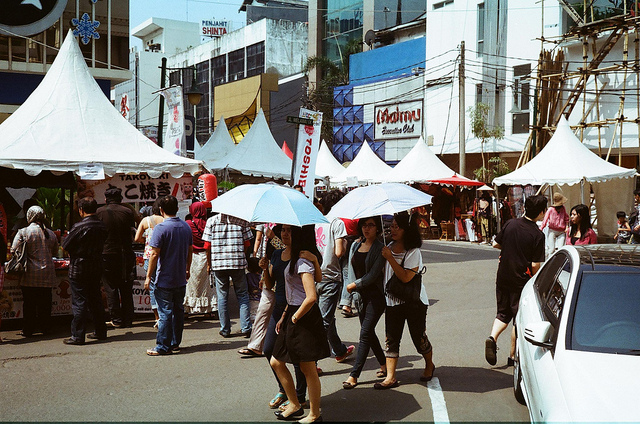Identify the text contained in this image. SHINTA Matrnu KOYA P TOSHIBA 